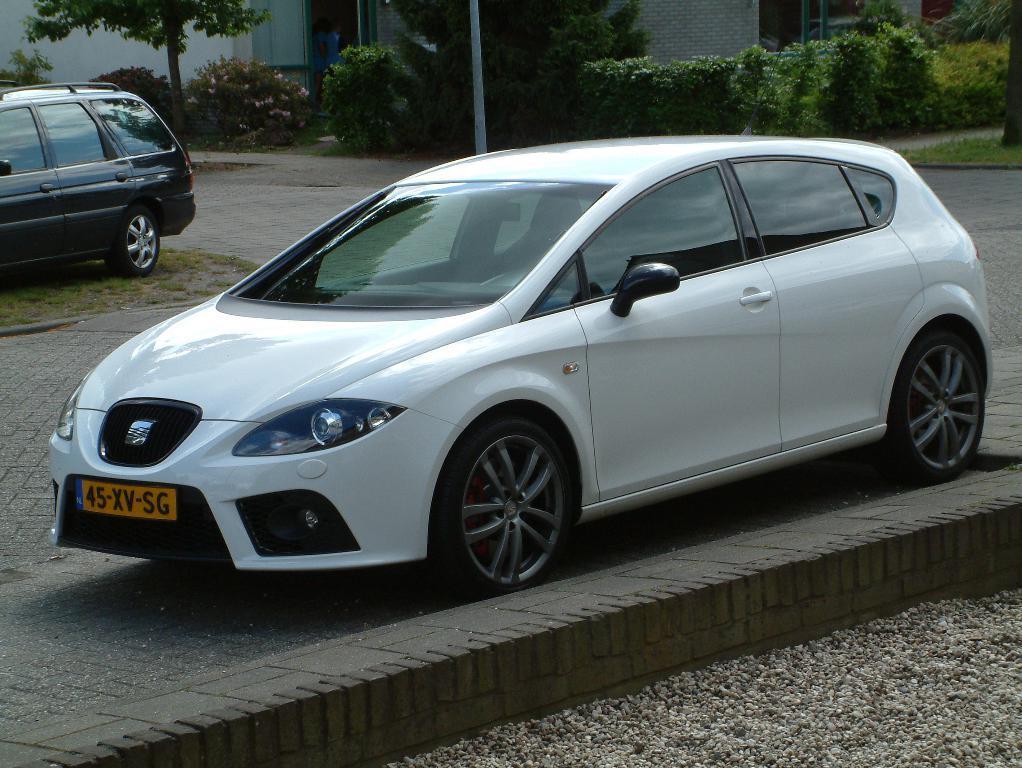How would you summarize this image in a sentence or two? In the center of the image there is a car on the road. On the left side of the image there is a car and tree. In the background there is a building, trees, plants and pole. 